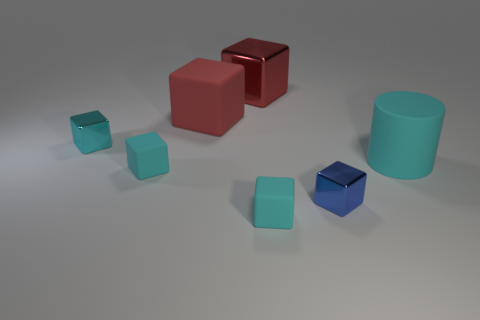Are there any large red objects of the same shape as the cyan metal object?
Your answer should be very brief. Yes. There is a metallic thing that is the same size as the blue block; what shape is it?
Your answer should be very brief. Cube. There is a small metal object that is behind the large cylinder; what is its shape?
Your answer should be compact. Cube. Are there fewer red blocks to the right of the small blue block than cyan shiny blocks left of the cyan shiny thing?
Ensure brevity in your answer.  No. Is the size of the rubber cylinder the same as the blue shiny block in front of the large red metallic block?
Offer a terse response. No. How many gray metallic objects have the same size as the red metal thing?
Provide a succinct answer. 0. What is the color of the small thing that is the same material as the blue cube?
Your answer should be very brief. Cyan. Is the number of small gray rubber cylinders greater than the number of matte cylinders?
Keep it short and to the point. No. Do the blue object and the large cyan thing have the same material?
Offer a terse response. No. There is a red thing that is the same material as the small blue object; what shape is it?
Keep it short and to the point. Cube. 